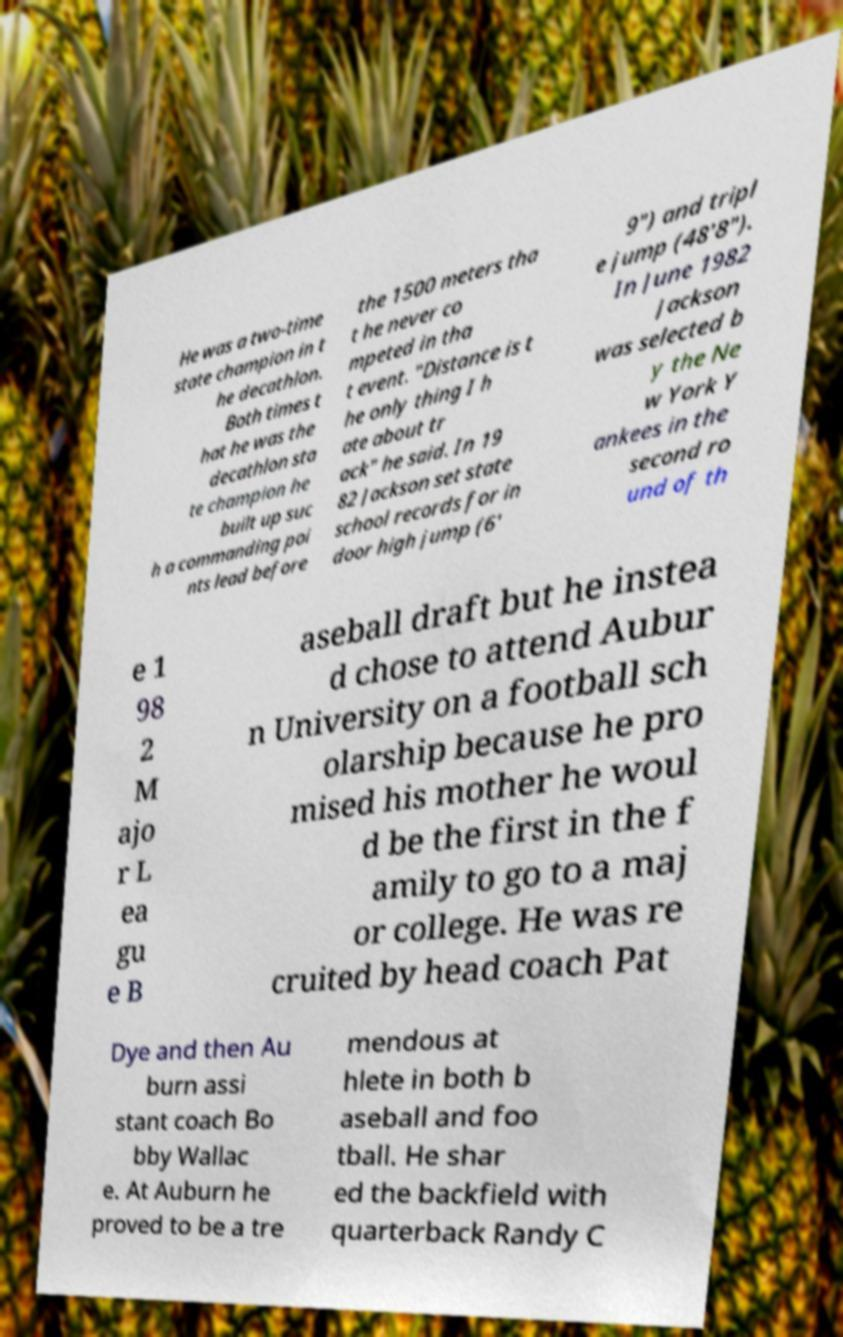Please read and relay the text visible in this image. What does it say? He was a two-time state champion in t he decathlon. Both times t hat he was the decathlon sta te champion he built up suc h a commanding poi nts lead before the 1500 meters tha t he never co mpeted in tha t event. "Distance is t he only thing I h ate about tr ack" he said. In 19 82 Jackson set state school records for in door high jump (6' 9") and tripl e jump (48'8"). In June 1982 Jackson was selected b y the Ne w York Y ankees in the second ro und of th e 1 98 2 M ajo r L ea gu e B aseball draft but he instea d chose to attend Aubur n University on a football sch olarship because he pro mised his mother he woul d be the first in the f amily to go to a maj or college. He was re cruited by head coach Pat Dye and then Au burn assi stant coach Bo bby Wallac e. At Auburn he proved to be a tre mendous at hlete in both b aseball and foo tball. He shar ed the backfield with quarterback Randy C 